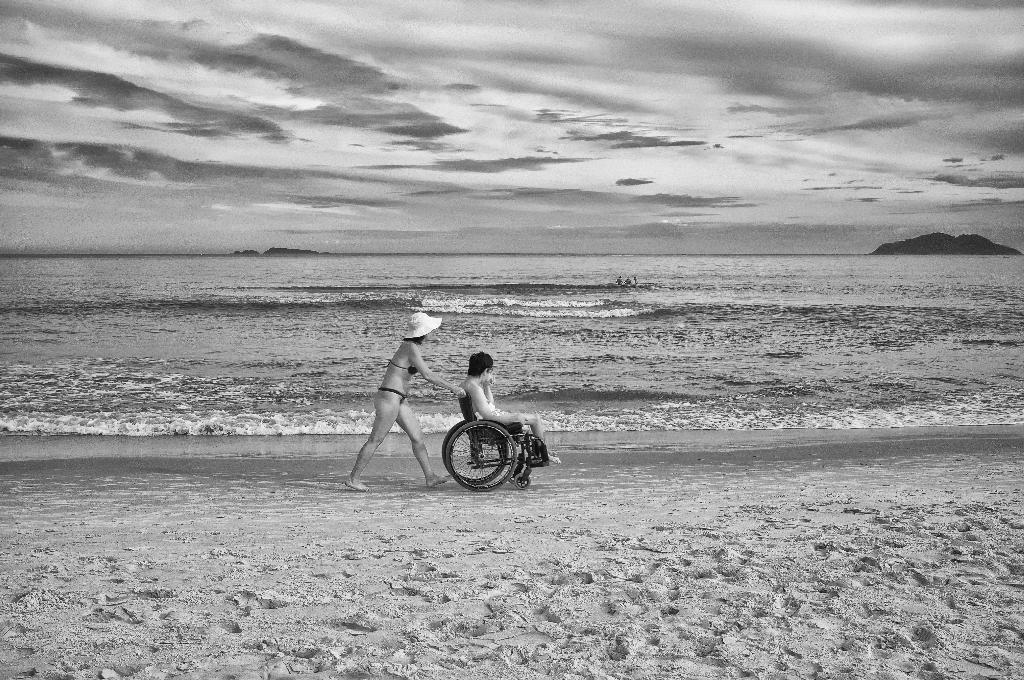Describe this image in one or two sentences. This is a black and white picture, we can see a few people in the sea, there are two persons on the sand, among them one is sitting in the wheel chair and the other one is holding the wheel chair. In the background, we can see the sky with clouds. 